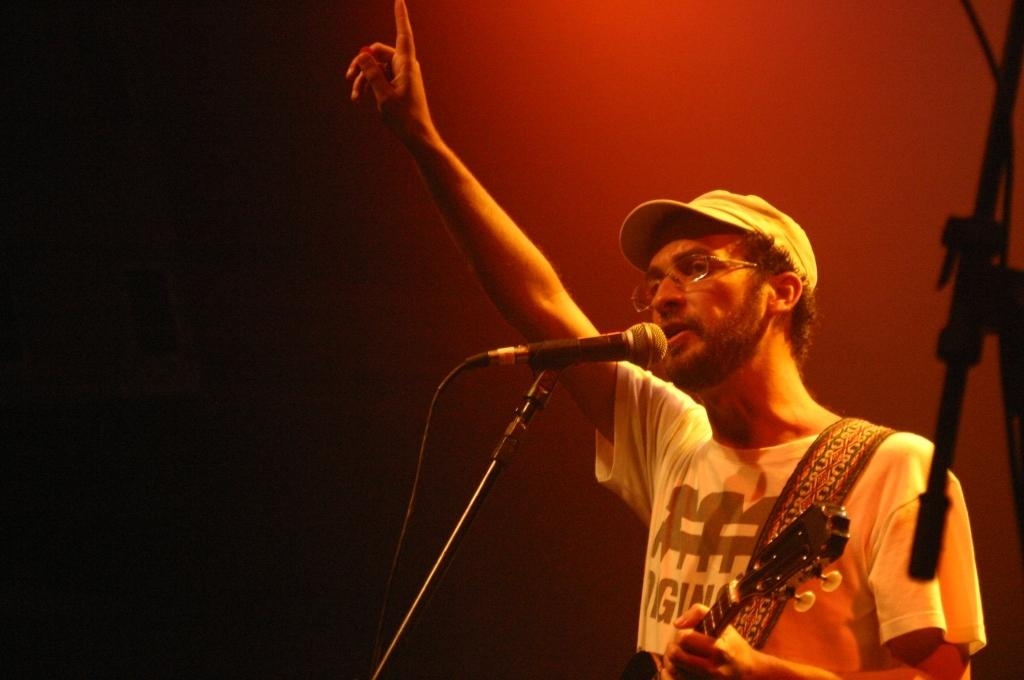Who is present in the image? There is a man in the image. What is the man holding in the image? The man is holding a guitar. What object is in front of the man? There is a microphone in front of the man. What type of yarn is the man using to play the guitar in the image? There is no yarn present in the image, and the man is not using any yarn to play the guitar. 